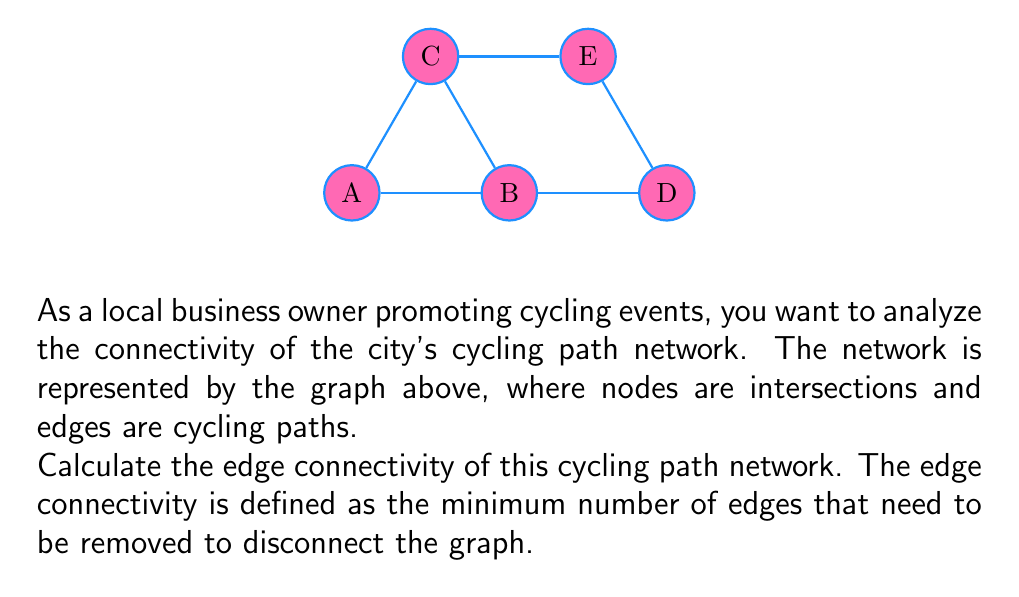What is the answer to this math problem? To find the edge connectivity of the graph, we need to identify the minimum cut set, which is the smallest set of edges whose removal would disconnect the graph.

Step 1: Analyze the graph structure.
The graph has 5 nodes (A, B, C, D, E) and 6 edges.

Step 2: Identify potential cut sets.
- Removing edge BC would not disconnect the graph.
- Removing edges AB and AC would disconnect A from the rest of the graph.
- Removing edges BD and CE would disconnect the graph into two components: {A,B,C} and {D,E}.

Step 3: Determine the minimum cut set.
The smallest cut set we found contains 2 edges (BD and CE).

Step 4: Verify that there is no smaller cut set.
- Removing any single edge does not disconnect the graph.
- We found a cut set of size 2, so we know the edge connectivity is at most 2.

Step 5: Conclude the edge connectivity.
Since we found a cut set of size 2 and verified that no single edge removal disconnects the graph, the edge connectivity of this graph is 2.

The edge connectivity represents the minimum number of cycling paths that would need to be closed to disconnect the network, which is valuable information for planning cycling events and understanding the robustness of the city's cycling infrastructure.
Answer: 2 